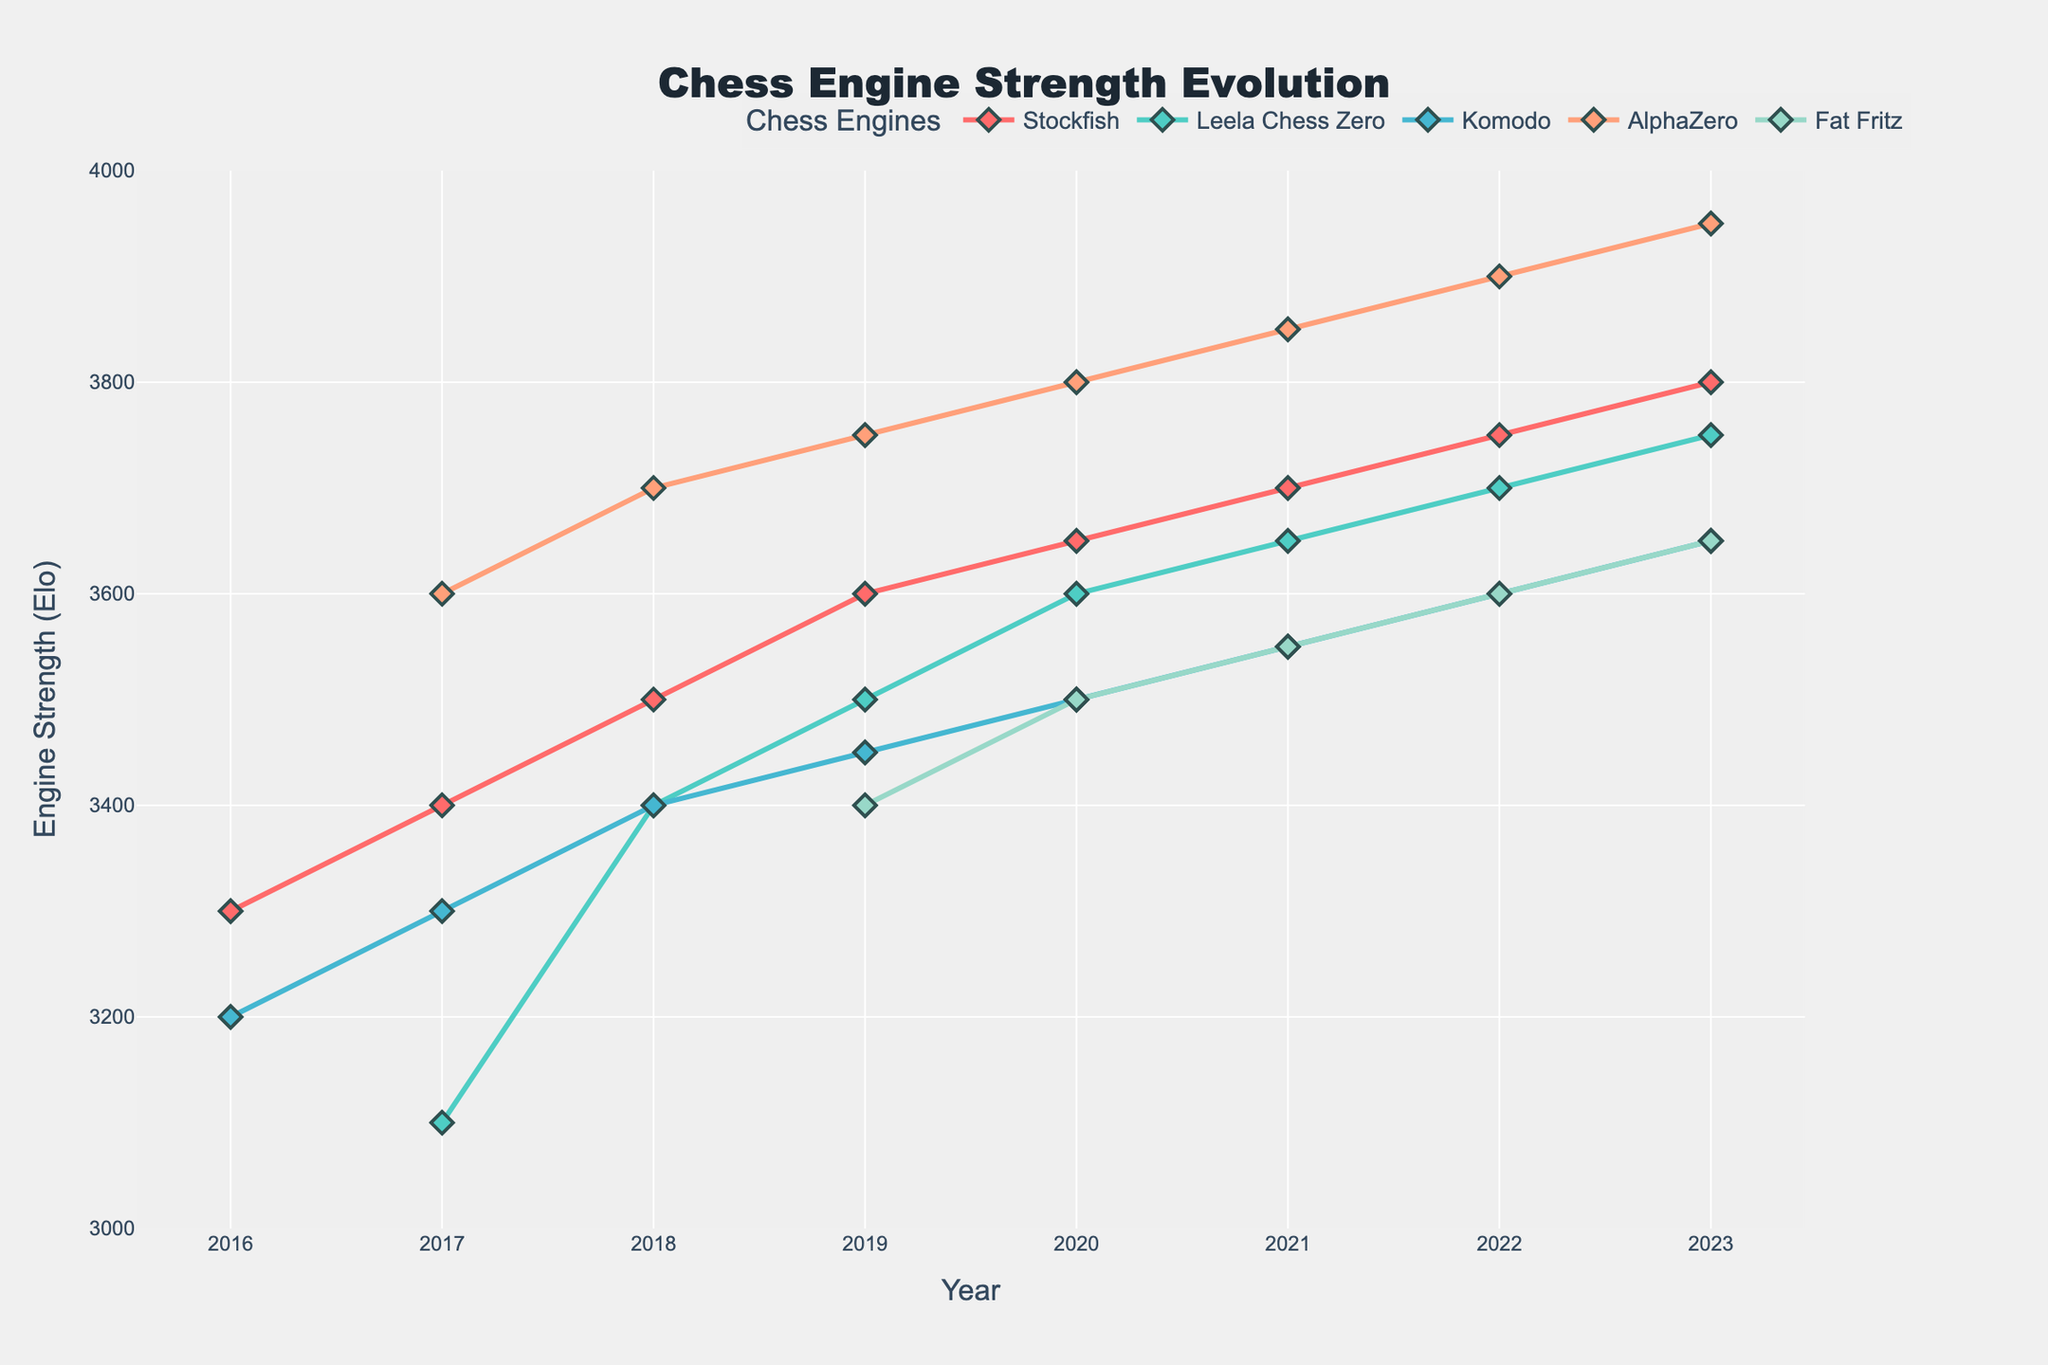Which chess engine had the highest Elo rating in 2020? Look at the 2020 data points and identify which engine had the highest value. AlphaZero had the highest Elo rating in 2020 with a value of 3800.
Answer: AlphaZero Between 2016 and 2023, which chess engines showed a consistent increase each year? Examine the trend lines of each engine from 2016 to 2023. Stockfish and Leela Chess Zero both showed a consistent increase each year.
Answer: Stockfish, Leela Chess Zero What is the difference in Elo rating between Stockfish and Komodo in 2023? Look at the 2023 data points for both Stockfish and Komodo. Stockfish had an Elo rating of 3800, and Komodo had an Elo rating of 3650. The difference is 3800 - 3650 = 150.
Answer: 150 Which engine had the fastest improvement in Elo between 2017 and 2018? Compare the Elo increase from 2017 to 2018 for each engine. Stockfish increased from 3400 to 3500, Leela Chess Zero from 3100 to 3400, Komodo from 3300 to 3400, and AlphaZero from 3600 to 3700. Leela Chess Zero showed the fastest improvement of 300 Elo points.
Answer: Leela Chess Zero How many engines reached an Elo rating of 3600 or higher in 2022? Look at the 2022 data points and count how many engines had an Elo rating of 3600 or higher. Stockfish, Leela Chess Zero, AlphaZero, and Fat Fritz all reached this mark, making a total of 4 engines.
Answer: 4 What is the average increase in Elo rating for Stockfish from 2016 to 2023? Calculate the total increase for Stockfish from 2016 (3300) to 2023 (3800), which is 3800 - 3300 = 500. Since this increase is over 7 years, the average increase per year is 500/7 = 71.43.
Answer: 71.43 Which engine's line color is blue? Observe the legend and corresponding lines. The Komodo engine's line is colored blue.
Answer: Komodo In which year did Fat Fritz join the comparison, and what was its initial Elo rating? Check the first year when Fat Fritz data is available and its corresponding Elo rating. Fat Fritz joined in 2019 with an initial Elo rating of 3400.
Answer: 2019, 3400 Which engine had the least improvement from 2019 to 2023? Calculate the differences for each engine from 2019 to 2023. For Stockfish: 3800-3600=200, Leela Chess Zero: 3750-3500=250, Komodo: 3650-3450=200, AlphaZero: 3950-3750=200, Fat Fritz: 3650-3400=250. Stockfish, Komodo, and AlphaZero each had an increase of 200.
Answer: Stockfish, Komodo, AlphaZero What is the median Elo rating of all the engines in 2021? Arrange the 2021 Elo ratings in ascending order: 3550 (Komodo, Fat Fritz), 3650 (Leela Chess Zero), 3700 (Stockfish), 3850 (AlphaZero). The median is the middle value, which is 3650 (rating of Leela Chess Zero).
Answer: 3650 